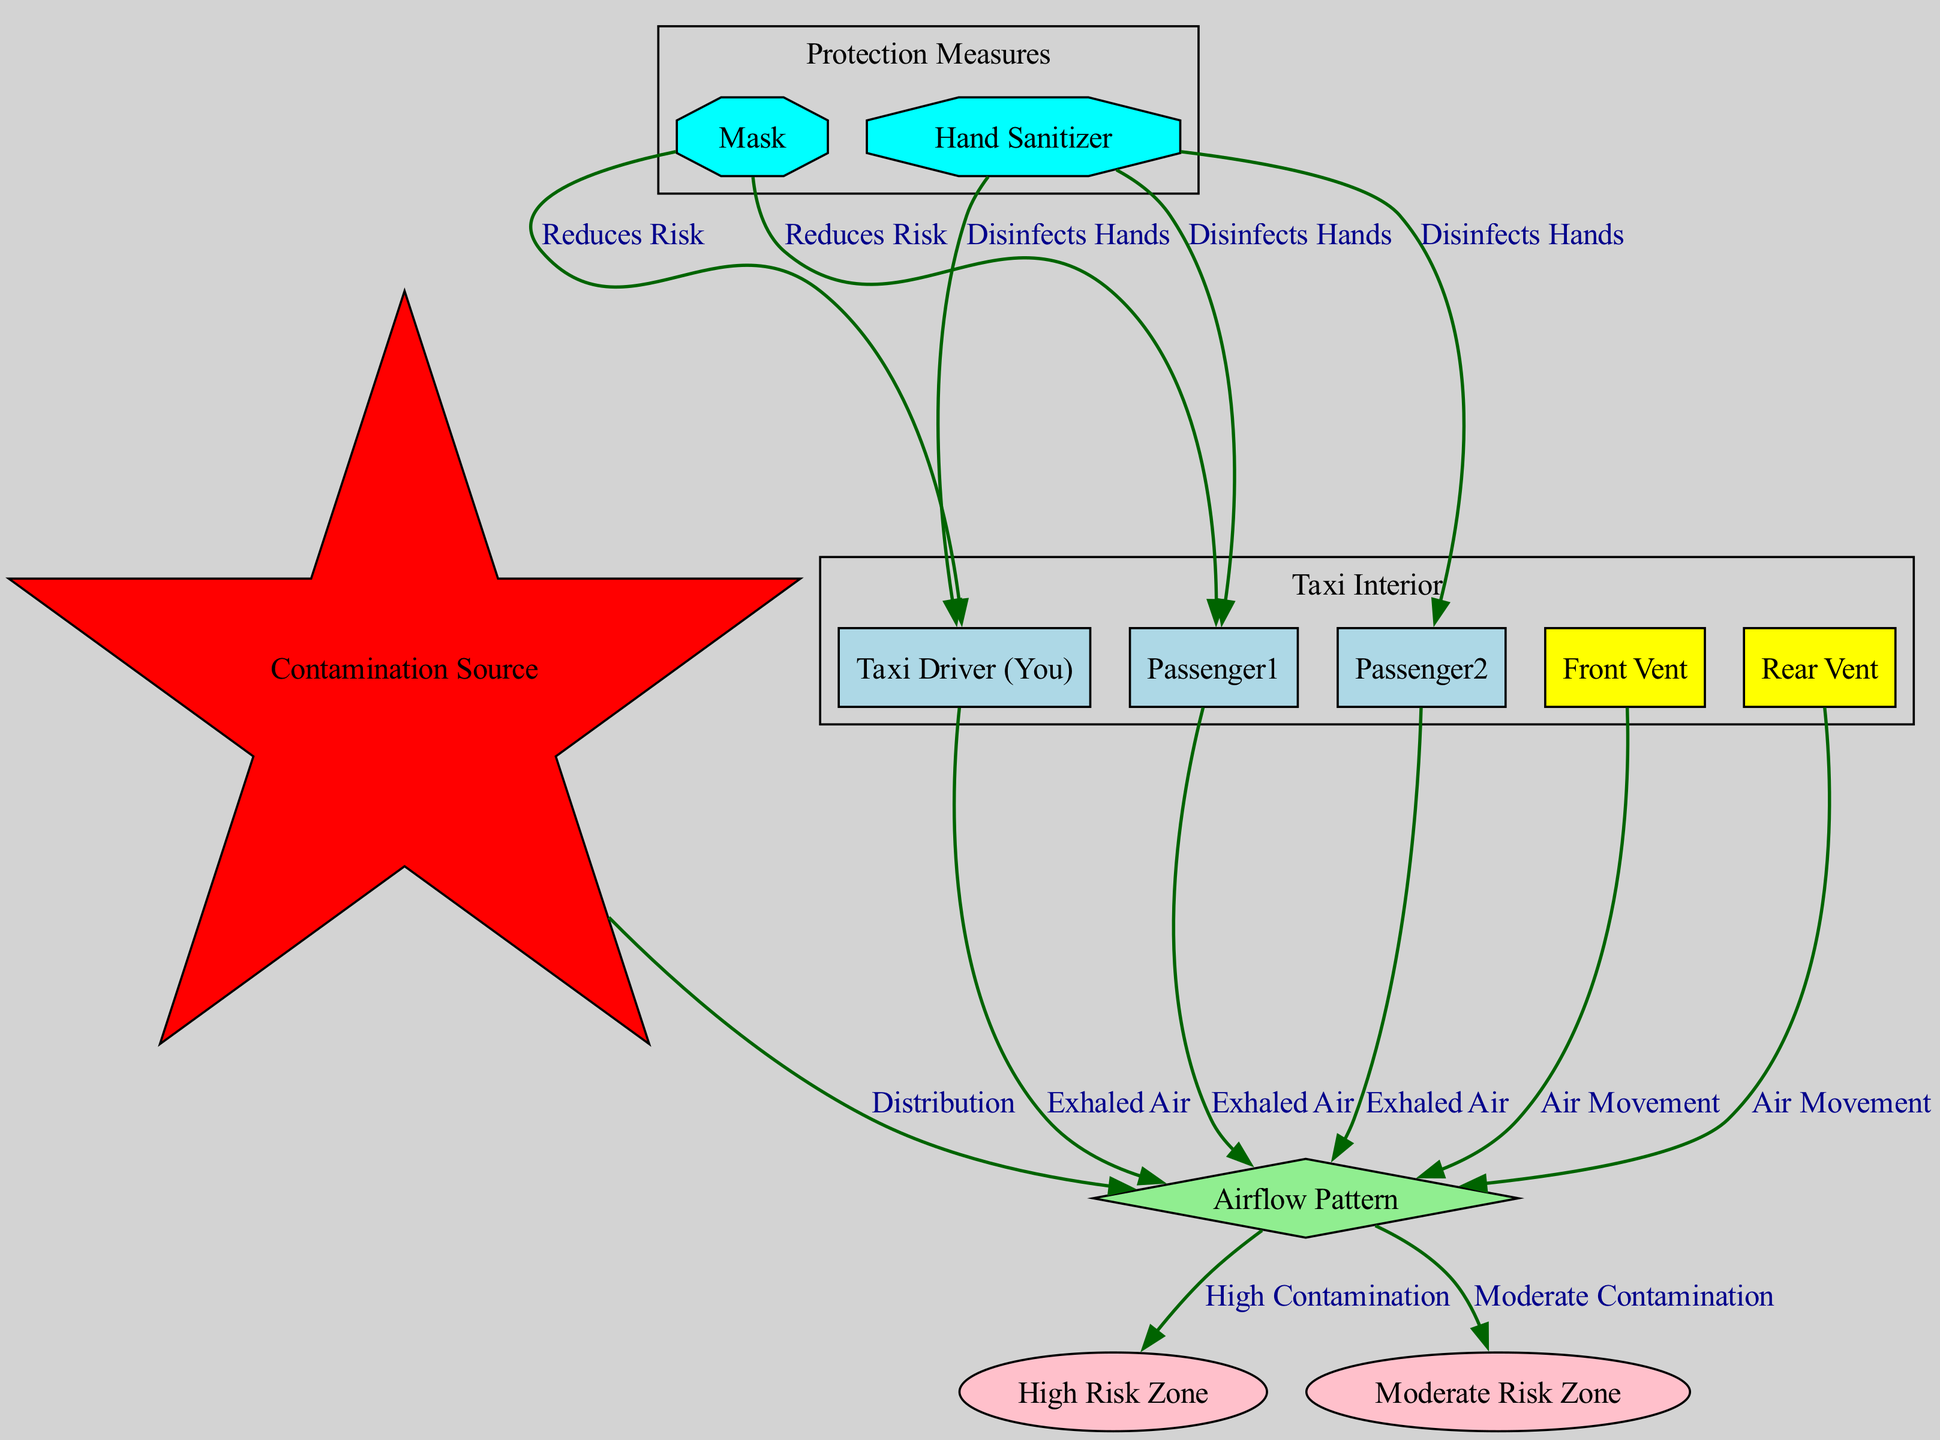What is the contamination source? The diagram has a node labeled "Contamination Source," which typically represents the origin from which the airborne pathogens are released into the airflow in the taxi. This node is key to understanding where the spread of the disease begins.
Answer: Contamination Source How many people are represented in the diagram? The diagram includes three distinct nodes labeled as "Taxi Driver (You)," "Passenger1," and "Passenger2." Thus, there are three people shown in the diagram.
Answer: 3 What is the label of the zone with high contamination? The diagram designates a zone specifically labeled "High Risk Zone," which indicates areas in the taxi where contamination is most likely to occur. This designation suggests that caution should be exercised in this area.
Answer: High Risk Zone Which node represents the airflow pattern? In the diagram, the node labeled "Airflow Pattern" illustrates how air moves within the taxi. This node is crucial for understanding how airborne diseases might spread through the vehicle's interior.
Answer: Airflow Pattern What effect does wearing a mask have according to the diagram? The diagram directly connects the nodes for both "Mask" and the individuals (driver and passenger1) with a label indicating "Reduces Risk." This suggests that wearing a mask lowers the likelihood of airborne disease transmission for those in the taxi.
Answer: Reduces Risk How many vents are shown in the diagram? There are two nodes labeled "Front Vent" and "Rear Vent" in the diagram, which signifies that the taxi is equipped with both front and rear ventilation options to manage airflow.
Answer: 2 What type of node is the "Hand Sanitizer"? The diagram categorizes "Hand Sanitizer" as a node of type "protection," which implies its role in mitigating the risk of disease transmission by disinfecting hands.
Answer: Protection What relationship exists between the airflow pattern and the contamination zones? The diagram connects the "Airflow Pattern" node to both "High Risk Zone" and "Moderate Risk Zone," indicating that the airflow pattern plays a significant role in distributing contaminants to different risk levels within the taxi.
Answer: Distribution What measures are indicated to reduce risk in the diagram? The diagram highlights two protective measures: "Mask" and "Hand Sanitizer," both of which are directly linked to the driver and passengers, illustrating the available methods to lower the risk of airborne disease spread while in the taxi.
Answer: Mask, Hand Sanitizer 